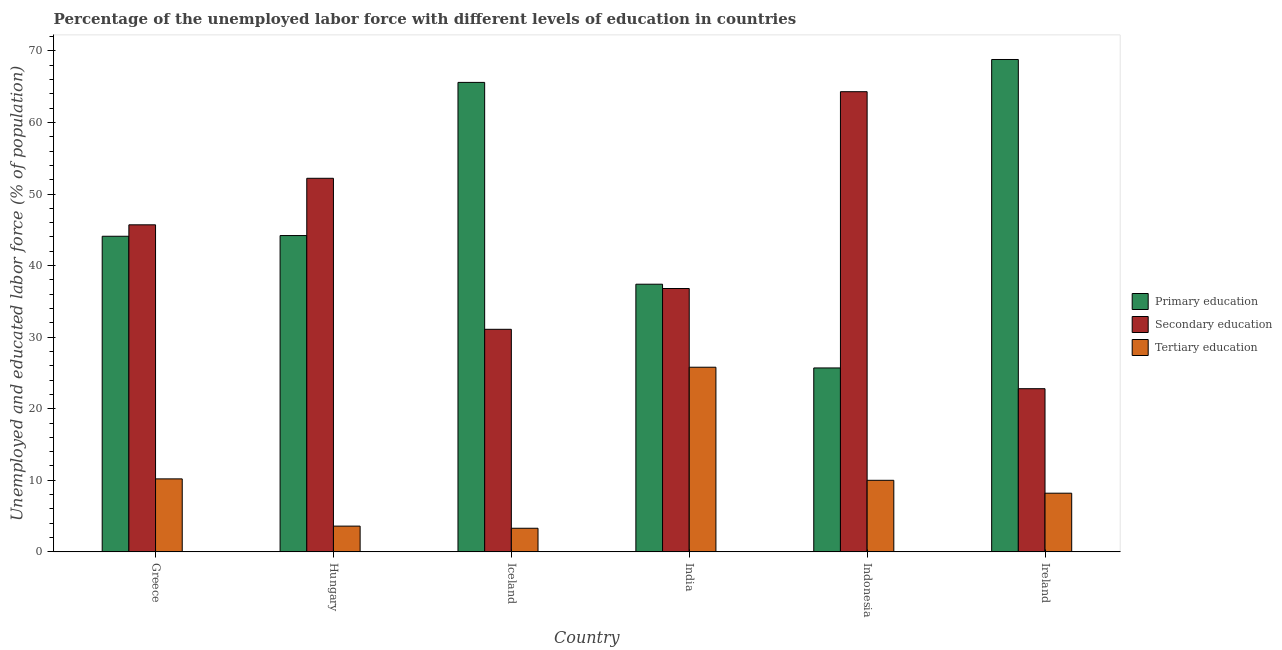Are the number of bars per tick equal to the number of legend labels?
Offer a terse response. Yes. Are the number of bars on each tick of the X-axis equal?
Your answer should be compact. Yes. How many bars are there on the 2nd tick from the left?
Give a very brief answer. 3. What is the label of the 4th group of bars from the left?
Ensure brevity in your answer.  India. In how many cases, is the number of bars for a given country not equal to the number of legend labels?
Make the answer very short. 0. What is the percentage of labor force who received tertiary education in Hungary?
Provide a succinct answer. 3.6. Across all countries, what is the maximum percentage of labor force who received tertiary education?
Your response must be concise. 25.8. Across all countries, what is the minimum percentage of labor force who received secondary education?
Your answer should be very brief. 22.8. In which country was the percentage of labor force who received secondary education maximum?
Make the answer very short. Indonesia. In which country was the percentage of labor force who received primary education minimum?
Your response must be concise. Indonesia. What is the total percentage of labor force who received primary education in the graph?
Keep it short and to the point. 285.8. What is the difference between the percentage of labor force who received secondary education in Greece and that in Ireland?
Offer a very short reply. 22.9. What is the difference between the percentage of labor force who received tertiary education in Hungary and the percentage of labor force who received secondary education in Ireland?
Your response must be concise. -19.2. What is the average percentage of labor force who received tertiary education per country?
Provide a succinct answer. 10.18. What is the difference between the percentage of labor force who received secondary education and percentage of labor force who received tertiary education in Greece?
Make the answer very short. 35.5. What is the ratio of the percentage of labor force who received tertiary education in India to that in Ireland?
Your answer should be compact. 3.15. Is the percentage of labor force who received primary education in Greece less than that in Indonesia?
Your answer should be compact. No. Is the difference between the percentage of labor force who received secondary education in India and Ireland greater than the difference between the percentage of labor force who received tertiary education in India and Ireland?
Make the answer very short. No. What is the difference between the highest and the second highest percentage of labor force who received primary education?
Offer a very short reply. 3.2. What is the difference between the highest and the lowest percentage of labor force who received secondary education?
Your response must be concise. 41.5. What does the 3rd bar from the left in India represents?
Offer a very short reply. Tertiary education. What does the 1st bar from the right in Iceland represents?
Your response must be concise. Tertiary education. Is it the case that in every country, the sum of the percentage of labor force who received primary education and percentage of labor force who received secondary education is greater than the percentage of labor force who received tertiary education?
Provide a succinct answer. Yes. Are all the bars in the graph horizontal?
Ensure brevity in your answer.  No. What is the difference between two consecutive major ticks on the Y-axis?
Your answer should be compact. 10. Does the graph contain any zero values?
Keep it short and to the point. No. Does the graph contain grids?
Your answer should be compact. No. Where does the legend appear in the graph?
Give a very brief answer. Center right. How are the legend labels stacked?
Offer a terse response. Vertical. What is the title of the graph?
Offer a terse response. Percentage of the unemployed labor force with different levels of education in countries. Does "Ages 60+" appear as one of the legend labels in the graph?
Your response must be concise. No. What is the label or title of the X-axis?
Offer a terse response. Country. What is the label or title of the Y-axis?
Your response must be concise. Unemployed and educated labor force (% of population). What is the Unemployed and educated labor force (% of population) of Primary education in Greece?
Your answer should be very brief. 44.1. What is the Unemployed and educated labor force (% of population) in Secondary education in Greece?
Provide a succinct answer. 45.7. What is the Unemployed and educated labor force (% of population) of Tertiary education in Greece?
Give a very brief answer. 10.2. What is the Unemployed and educated labor force (% of population) of Primary education in Hungary?
Your answer should be very brief. 44.2. What is the Unemployed and educated labor force (% of population) of Secondary education in Hungary?
Offer a terse response. 52.2. What is the Unemployed and educated labor force (% of population) in Tertiary education in Hungary?
Your answer should be very brief. 3.6. What is the Unemployed and educated labor force (% of population) in Primary education in Iceland?
Keep it short and to the point. 65.6. What is the Unemployed and educated labor force (% of population) of Secondary education in Iceland?
Keep it short and to the point. 31.1. What is the Unemployed and educated labor force (% of population) in Tertiary education in Iceland?
Provide a succinct answer. 3.3. What is the Unemployed and educated labor force (% of population) of Primary education in India?
Give a very brief answer. 37.4. What is the Unemployed and educated labor force (% of population) of Secondary education in India?
Keep it short and to the point. 36.8. What is the Unemployed and educated labor force (% of population) in Tertiary education in India?
Your answer should be compact. 25.8. What is the Unemployed and educated labor force (% of population) of Primary education in Indonesia?
Make the answer very short. 25.7. What is the Unemployed and educated labor force (% of population) in Secondary education in Indonesia?
Your answer should be compact. 64.3. What is the Unemployed and educated labor force (% of population) of Primary education in Ireland?
Your answer should be very brief. 68.8. What is the Unemployed and educated labor force (% of population) of Secondary education in Ireland?
Your answer should be very brief. 22.8. What is the Unemployed and educated labor force (% of population) of Tertiary education in Ireland?
Provide a succinct answer. 8.2. Across all countries, what is the maximum Unemployed and educated labor force (% of population) in Primary education?
Give a very brief answer. 68.8. Across all countries, what is the maximum Unemployed and educated labor force (% of population) in Secondary education?
Your response must be concise. 64.3. Across all countries, what is the maximum Unemployed and educated labor force (% of population) in Tertiary education?
Offer a terse response. 25.8. Across all countries, what is the minimum Unemployed and educated labor force (% of population) of Primary education?
Offer a very short reply. 25.7. Across all countries, what is the minimum Unemployed and educated labor force (% of population) in Secondary education?
Your response must be concise. 22.8. Across all countries, what is the minimum Unemployed and educated labor force (% of population) of Tertiary education?
Offer a terse response. 3.3. What is the total Unemployed and educated labor force (% of population) of Primary education in the graph?
Offer a terse response. 285.8. What is the total Unemployed and educated labor force (% of population) in Secondary education in the graph?
Keep it short and to the point. 252.9. What is the total Unemployed and educated labor force (% of population) in Tertiary education in the graph?
Offer a terse response. 61.1. What is the difference between the Unemployed and educated labor force (% of population) of Secondary education in Greece and that in Hungary?
Keep it short and to the point. -6.5. What is the difference between the Unemployed and educated labor force (% of population) in Tertiary education in Greece and that in Hungary?
Provide a succinct answer. 6.6. What is the difference between the Unemployed and educated labor force (% of population) in Primary education in Greece and that in Iceland?
Give a very brief answer. -21.5. What is the difference between the Unemployed and educated labor force (% of population) in Primary education in Greece and that in India?
Give a very brief answer. 6.7. What is the difference between the Unemployed and educated labor force (% of population) of Tertiary education in Greece and that in India?
Provide a succinct answer. -15.6. What is the difference between the Unemployed and educated labor force (% of population) of Primary education in Greece and that in Indonesia?
Provide a succinct answer. 18.4. What is the difference between the Unemployed and educated labor force (% of population) of Secondary education in Greece and that in Indonesia?
Provide a succinct answer. -18.6. What is the difference between the Unemployed and educated labor force (% of population) of Primary education in Greece and that in Ireland?
Provide a succinct answer. -24.7. What is the difference between the Unemployed and educated labor force (% of population) in Secondary education in Greece and that in Ireland?
Your response must be concise. 22.9. What is the difference between the Unemployed and educated labor force (% of population) of Primary education in Hungary and that in Iceland?
Make the answer very short. -21.4. What is the difference between the Unemployed and educated labor force (% of population) of Secondary education in Hungary and that in Iceland?
Give a very brief answer. 21.1. What is the difference between the Unemployed and educated labor force (% of population) in Primary education in Hungary and that in India?
Provide a short and direct response. 6.8. What is the difference between the Unemployed and educated labor force (% of population) of Secondary education in Hungary and that in India?
Give a very brief answer. 15.4. What is the difference between the Unemployed and educated labor force (% of population) of Tertiary education in Hungary and that in India?
Make the answer very short. -22.2. What is the difference between the Unemployed and educated labor force (% of population) of Primary education in Hungary and that in Indonesia?
Provide a succinct answer. 18.5. What is the difference between the Unemployed and educated labor force (% of population) of Secondary education in Hungary and that in Indonesia?
Offer a terse response. -12.1. What is the difference between the Unemployed and educated labor force (% of population) in Tertiary education in Hungary and that in Indonesia?
Your answer should be very brief. -6.4. What is the difference between the Unemployed and educated labor force (% of population) in Primary education in Hungary and that in Ireland?
Make the answer very short. -24.6. What is the difference between the Unemployed and educated labor force (% of population) in Secondary education in Hungary and that in Ireland?
Offer a terse response. 29.4. What is the difference between the Unemployed and educated labor force (% of population) of Tertiary education in Hungary and that in Ireland?
Your answer should be very brief. -4.6. What is the difference between the Unemployed and educated labor force (% of population) in Primary education in Iceland and that in India?
Offer a terse response. 28.2. What is the difference between the Unemployed and educated labor force (% of population) in Tertiary education in Iceland and that in India?
Provide a short and direct response. -22.5. What is the difference between the Unemployed and educated labor force (% of population) of Primary education in Iceland and that in Indonesia?
Offer a terse response. 39.9. What is the difference between the Unemployed and educated labor force (% of population) in Secondary education in Iceland and that in Indonesia?
Your answer should be compact. -33.2. What is the difference between the Unemployed and educated labor force (% of population) of Secondary education in India and that in Indonesia?
Provide a short and direct response. -27.5. What is the difference between the Unemployed and educated labor force (% of population) of Primary education in India and that in Ireland?
Ensure brevity in your answer.  -31.4. What is the difference between the Unemployed and educated labor force (% of population) of Tertiary education in India and that in Ireland?
Make the answer very short. 17.6. What is the difference between the Unemployed and educated labor force (% of population) in Primary education in Indonesia and that in Ireland?
Make the answer very short. -43.1. What is the difference between the Unemployed and educated labor force (% of population) in Secondary education in Indonesia and that in Ireland?
Your answer should be very brief. 41.5. What is the difference between the Unemployed and educated labor force (% of population) in Tertiary education in Indonesia and that in Ireland?
Give a very brief answer. 1.8. What is the difference between the Unemployed and educated labor force (% of population) of Primary education in Greece and the Unemployed and educated labor force (% of population) of Secondary education in Hungary?
Your answer should be very brief. -8.1. What is the difference between the Unemployed and educated labor force (% of population) of Primary education in Greece and the Unemployed and educated labor force (% of population) of Tertiary education in Hungary?
Your answer should be compact. 40.5. What is the difference between the Unemployed and educated labor force (% of population) of Secondary education in Greece and the Unemployed and educated labor force (% of population) of Tertiary education in Hungary?
Your answer should be very brief. 42.1. What is the difference between the Unemployed and educated labor force (% of population) in Primary education in Greece and the Unemployed and educated labor force (% of population) in Tertiary education in Iceland?
Make the answer very short. 40.8. What is the difference between the Unemployed and educated labor force (% of population) of Secondary education in Greece and the Unemployed and educated labor force (% of population) of Tertiary education in Iceland?
Offer a very short reply. 42.4. What is the difference between the Unemployed and educated labor force (% of population) in Primary education in Greece and the Unemployed and educated labor force (% of population) in Secondary education in India?
Your answer should be compact. 7.3. What is the difference between the Unemployed and educated labor force (% of population) of Secondary education in Greece and the Unemployed and educated labor force (% of population) of Tertiary education in India?
Provide a succinct answer. 19.9. What is the difference between the Unemployed and educated labor force (% of population) in Primary education in Greece and the Unemployed and educated labor force (% of population) in Secondary education in Indonesia?
Make the answer very short. -20.2. What is the difference between the Unemployed and educated labor force (% of population) in Primary education in Greece and the Unemployed and educated labor force (% of population) in Tertiary education in Indonesia?
Your answer should be very brief. 34.1. What is the difference between the Unemployed and educated labor force (% of population) of Secondary education in Greece and the Unemployed and educated labor force (% of population) of Tertiary education in Indonesia?
Make the answer very short. 35.7. What is the difference between the Unemployed and educated labor force (% of population) in Primary education in Greece and the Unemployed and educated labor force (% of population) in Secondary education in Ireland?
Keep it short and to the point. 21.3. What is the difference between the Unemployed and educated labor force (% of population) of Primary education in Greece and the Unemployed and educated labor force (% of population) of Tertiary education in Ireland?
Offer a terse response. 35.9. What is the difference between the Unemployed and educated labor force (% of population) in Secondary education in Greece and the Unemployed and educated labor force (% of population) in Tertiary education in Ireland?
Your answer should be compact. 37.5. What is the difference between the Unemployed and educated labor force (% of population) in Primary education in Hungary and the Unemployed and educated labor force (% of population) in Tertiary education in Iceland?
Offer a very short reply. 40.9. What is the difference between the Unemployed and educated labor force (% of population) of Secondary education in Hungary and the Unemployed and educated labor force (% of population) of Tertiary education in Iceland?
Offer a terse response. 48.9. What is the difference between the Unemployed and educated labor force (% of population) in Primary education in Hungary and the Unemployed and educated labor force (% of population) in Secondary education in India?
Offer a very short reply. 7.4. What is the difference between the Unemployed and educated labor force (% of population) of Primary education in Hungary and the Unemployed and educated labor force (% of population) of Tertiary education in India?
Your answer should be very brief. 18.4. What is the difference between the Unemployed and educated labor force (% of population) in Secondary education in Hungary and the Unemployed and educated labor force (% of population) in Tertiary education in India?
Keep it short and to the point. 26.4. What is the difference between the Unemployed and educated labor force (% of population) in Primary education in Hungary and the Unemployed and educated labor force (% of population) in Secondary education in Indonesia?
Keep it short and to the point. -20.1. What is the difference between the Unemployed and educated labor force (% of population) of Primary education in Hungary and the Unemployed and educated labor force (% of population) of Tertiary education in Indonesia?
Your answer should be compact. 34.2. What is the difference between the Unemployed and educated labor force (% of population) in Secondary education in Hungary and the Unemployed and educated labor force (% of population) in Tertiary education in Indonesia?
Offer a terse response. 42.2. What is the difference between the Unemployed and educated labor force (% of population) in Primary education in Hungary and the Unemployed and educated labor force (% of population) in Secondary education in Ireland?
Your answer should be compact. 21.4. What is the difference between the Unemployed and educated labor force (% of population) of Primary education in Hungary and the Unemployed and educated labor force (% of population) of Tertiary education in Ireland?
Ensure brevity in your answer.  36. What is the difference between the Unemployed and educated labor force (% of population) in Primary education in Iceland and the Unemployed and educated labor force (% of population) in Secondary education in India?
Give a very brief answer. 28.8. What is the difference between the Unemployed and educated labor force (% of population) in Primary education in Iceland and the Unemployed and educated labor force (% of population) in Tertiary education in India?
Your answer should be very brief. 39.8. What is the difference between the Unemployed and educated labor force (% of population) in Primary education in Iceland and the Unemployed and educated labor force (% of population) in Secondary education in Indonesia?
Keep it short and to the point. 1.3. What is the difference between the Unemployed and educated labor force (% of population) of Primary education in Iceland and the Unemployed and educated labor force (% of population) of Tertiary education in Indonesia?
Your answer should be very brief. 55.6. What is the difference between the Unemployed and educated labor force (% of population) of Secondary education in Iceland and the Unemployed and educated labor force (% of population) of Tertiary education in Indonesia?
Keep it short and to the point. 21.1. What is the difference between the Unemployed and educated labor force (% of population) of Primary education in Iceland and the Unemployed and educated labor force (% of population) of Secondary education in Ireland?
Your response must be concise. 42.8. What is the difference between the Unemployed and educated labor force (% of population) in Primary education in Iceland and the Unemployed and educated labor force (% of population) in Tertiary education in Ireland?
Provide a succinct answer. 57.4. What is the difference between the Unemployed and educated labor force (% of population) of Secondary education in Iceland and the Unemployed and educated labor force (% of population) of Tertiary education in Ireland?
Provide a short and direct response. 22.9. What is the difference between the Unemployed and educated labor force (% of population) of Primary education in India and the Unemployed and educated labor force (% of population) of Secondary education in Indonesia?
Offer a terse response. -26.9. What is the difference between the Unemployed and educated labor force (% of population) in Primary education in India and the Unemployed and educated labor force (% of population) in Tertiary education in Indonesia?
Give a very brief answer. 27.4. What is the difference between the Unemployed and educated labor force (% of population) of Secondary education in India and the Unemployed and educated labor force (% of population) of Tertiary education in Indonesia?
Provide a short and direct response. 26.8. What is the difference between the Unemployed and educated labor force (% of population) of Primary education in India and the Unemployed and educated labor force (% of population) of Tertiary education in Ireland?
Ensure brevity in your answer.  29.2. What is the difference between the Unemployed and educated labor force (% of population) of Secondary education in India and the Unemployed and educated labor force (% of population) of Tertiary education in Ireland?
Your answer should be very brief. 28.6. What is the difference between the Unemployed and educated labor force (% of population) of Secondary education in Indonesia and the Unemployed and educated labor force (% of population) of Tertiary education in Ireland?
Offer a terse response. 56.1. What is the average Unemployed and educated labor force (% of population) of Primary education per country?
Offer a very short reply. 47.63. What is the average Unemployed and educated labor force (% of population) of Secondary education per country?
Your answer should be very brief. 42.15. What is the average Unemployed and educated labor force (% of population) in Tertiary education per country?
Offer a very short reply. 10.18. What is the difference between the Unemployed and educated labor force (% of population) in Primary education and Unemployed and educated labor force (% of population) in Tertiary education in Greece?
Ensure brevity in your answer.  33.9. What is the difference between the Unemployed and educated labor force (% of population) of Secondary education and Unemployed and educated labor force (% of population) of Tertiary education in Greece?
Keep it short and to the point. 35.5. What is the difference between the Unemployed and educated labor force (% of population) in Primary education and Unemployed and educated labor force (% of population) in Tertiary education in Hungary?
Offer a very short reply. 40.6. What is the difference between the Unemployed and educated labor force (% of population) of Secondary education and Unemployed and educated labor force (% of population) of Tertiary education in Hungary?
Your response must be concise. 48.6. What is the difference between the Unemployed and educated labor force (% of population) of Primary education and Unemployed and educated labor force (% of population) of Secondary education in Iceland?
Provide a succinct answer. 34.5. What is the difference between the Unemployed and educated labor force (% of population) of Primary education and Unemployed and educated labor force (% of population) of Tertiary education in Iceland?
Provide a succinct answer. 62.3. What is the difference between the Unemployed and educated labor force (% of population) in Secondary education and Unemployed and educated labor force (% of population) in Tertiary education in Iceland?
Your response must be concise. 27.8. What is the difference between the Unemployed and educated labor force (% of population) in Primary education and Unemployed and educated labor force (% of population) in Tertiary education in India?
Offer a very short reply. 11.6. What is the difference between the Unemployed and educated labor force (% of population) of Secondary education and Unemployed and educated labor force (% of population) of Tertiary education in India?
Ensure brevity in your answer.  11. What is the difference between the Unemployed and educated labor force (% of population) of Primary education and Unemployed and educated labor force (% of population) of Secondary education in Indonesia?
Offer a terse response. -38.6. What is the difference between the Unemployed and educated labor force (% of population) in Primary education and Unemployed and educated labor force (% of population) in Tertiary education in Indonesia?
Provide a short and direct response. 15.7. What is the difference between the Unemployed and educated labor force (% of population) in Secondary education and Unemployed and educated labor force (% of population) in Tertiary education in Indonesia?
Make the answer very short. 54.3. What is the difference between the Unemployed and educated labor force (% of population) of Primary education and Unemployed and educated labor force (% of population) of Secondary education in Ireland?
Make the answer very short. 46. What is the difference between the Unemployed and educated labor force (% of population) of Primary education and Unemployed and educated labor force (% of population) of Tertiary education in Ireland?
Your response must be concise. 60.6. What is the ratio of the Unemployed and educated labor force (% of population) of Primary education in Greece to that in Hungary?
Your answer should be very brief. 1. What is the ratio of the Unemployed and educated labor force (% of population) in Secondary education in Greece to that in Hungary?
Make the answer very short. 0.88. What is the ratio of the Unemployed and educated labor force (% of population) of Tertiary education in Greece to that in Hungary?
Provide a succinct answer. 2.83. What is the ratio of the Unemployed and educated labor force (% of population) of Primary education in Greece to that in Iceland?
Give a very brief answer. 0.67. What is the ratio of the Unemployed and educated labor force (% of population) of Secondary education in Greece to that in Iceland?
Provide a short and direct response. 1.47. What is the ratio of the Unemployed and educated labor force (% of population) of Tertiary education in Greece to that in Iceland?
Your response must be concise. 3.09. What is the ratio of the Unemployed and educated labor force (% of population) of Primary education in Greece to that in India?
Offer a terse response. 1.18. What is the ratio of the Unemployed and educated labor force (% of population) in Secondary education in Greece to that in India?
Offer a terse response. 1.24. What is the ratio of the Unemployed and educated labor force (% of population) of Tertiary education in Greece to that in India?
Your response must be concise. 0.4. What is the ratio of the Unemployed and educated labor force (% of population) in Primary education in Greece to that in Indonesia?
Your response must be concise. 1.72. What is the ratio of the Unemployed and educated labor force (% of population) of Secondary education in Greece to that in Indonesia?
Your response must be concise. 0.71. What is the ratio of the Unemployed and educated labor force (% of population) in Primary education in Greece to that in Ireland?
Ensure brevity in your answer.  0.64. What is the ratio of the Unemployed and educated labor force (% of population) of Secondary education in Greece to that in Ireland?
Offer a terse response. 2. What is the ratio of the Unemployed and educated labor force (% of population) of Tertiary education in Greece to that in Ireland?
Your answer should be compact. 1.24. What is the ratio of the Unemployed and educated labor force (% of population) of Primary education in Hungary to that in Iceland?
Offer a terse response. 0.67. What is the ratio of the Unemployed and educated labor force (% of population) of Secondary education in Hungary to that in Iceland?
Provide a short and direct response. 1.68. What is the ratio of the Unemployed and educated labor force (% of population) of Primary education in Hungary to that in India?
Your response must be concise. 1.18. What is the ratio of the Unemployed and educated labor force (% of population) of Secondary education in Hungary to that in India?
Offer a terse response. 1.42. What is the ratio of the Unemployed and educated labor force (% of population) of Tertiary education in Hungary to that in India?
Ensure brevity in your answer.  0.14. What is the ratio of the Unemployed and educated labor force (% of population) of Primary education in Hungary to that in Indonesia?
Your response must be concise. 1.72. What is the ratio of the Unemployed and educated labor force (% of population) in Secondary education in Hungary to that in Indonesia?
Give a very brief answer. 0.81. What is the ratio of the Unemployed and educated labor force (% of population) in Tertiary education in Hungary to that in Indonesia?
Give a very brief answer. 0.36. What is the ratio of the Unemployed and educated labor force (% of population) in Primary education in Hungary to that in Ireland?
Give a very brief answer. 0.64. What is the ratio of the Unemployed and educated labor force (% of population) of Secondary education in Hungary to that in Ireland?
Your response must be concise. 2.29. What is the ratio of the Unemployed and educated labor force (% of population) of Tertiary education in Hungary to that in Ireland?
Your answer should be compact. 0.44. What is the ratio of the Unemployed and educated labor force (% of population) in Primary education in Iceland to that in India?
Offer a terse response. 1.75. What is the ratio of the Unemployed and educated labor force (% of population) in Secondary education in Iceland to that in India?
Keep it short and to the point. 0.85. What is the ratio of the Unemployed and educated labor force (% of population) in Tertiary education in Iceland to that in India?
Your response must be concise. 0.13. What is the ratio of the Unemployed and educated labor force (% of population) of Primary education in Iceland to that in Indonesia?
Your answer should be very brief. 2.55. What is the ratio of the Unemployed and educated labor force (% of population) of Secondary education in Iceland to that in Indonesia?
Keep it short and to the point. 0.48. What is the ratio of the Unemployed and educated labor force (% of population) in Tertiary education in Iceland to that in Indonesia?
Give a very brief answer. 0.33. What is the ratio of the Unemployed and educated labor force (% of population) of Primary education in Iceland to that in Ireland?
Your answer should be very brief. 0.95. What is the ratio of the Unemployed and educated labor force (% of population) in Secondary education in Iceland to that in Ireland?
Your answer should be compact. 1.36. What is the ratio of the Unemployed and educated labor force (% of population) of Tertiary education in Iceland to that in Ireland?
Provide a succinct answer. 0.4. What is the ratio of the Unemployed and educated labor force (% of population) of Primary education in India to that in Indonesia?
Ensure brevity in your answer.  1.46. What is the ratio of the Unemployed and educated labor force (% of population) in Secondary education in India to that in Indonesia?
Offer a terse response. 0.57. What is the ratio of the Unemployed and educated labor force (% of population) of Tertiary education in India to that in Indonesia?
Ensure brevity in your answer.  2.58. What is the ratio of the Unemployed and educated labor force (% of population) in Primary education in India to that in Ireland?
Offer a very short reply. 0.54. What is the ratio of the Unemployed and educated labor force (% of population) of Secondary education in India to that in Ireland?
Offer a very short reply. 1.61. What is the ratio of the Unemployed and educated labor force (% of population) of Tertiary education in India to that in Ireland?
Offer a terse response. 3.15. What is the ratio of the Unemployed and educated labor force (% of population) of Primary education in Indonesia to that in Ireland?
Give a very brief answer. 0.37. What is the ratio of the Unemployed and educated labor force (% of population) in Secondary education in Indonesia to that in Ireland?
Your response must be concise. 2.82. What is the ratio of the Unemployed and educated labor force (% of population) of Tertiary education in Indonesia to that in Ireland?
Offer a very short reply. 1.22. What is the difference between the highest and the second highest Unemployed and educated labor force (% of population) in Tertiary education?
Make the answer very short. 15.6. What is the difference between the highest and the lowest Unemployed and educated labor force (% of population) of Primary education?
Your answer should be compact. 43.1. What is the difference between the highest and the lowest Unemployed and educated labor force (% of population) in Secondary education?
Give a very brief answer. 41.5. What is the difference between the highest and the lowest Unemployed and educated labor force (% of population) in Tertiary education?
Ensure brevity in your answer.  22.5. 